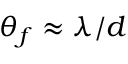Convert formula to latex. <formula><loc_0><loc_0><loc_500><loc_500>\theta _ { f } \approx \lambda / d</formula> 